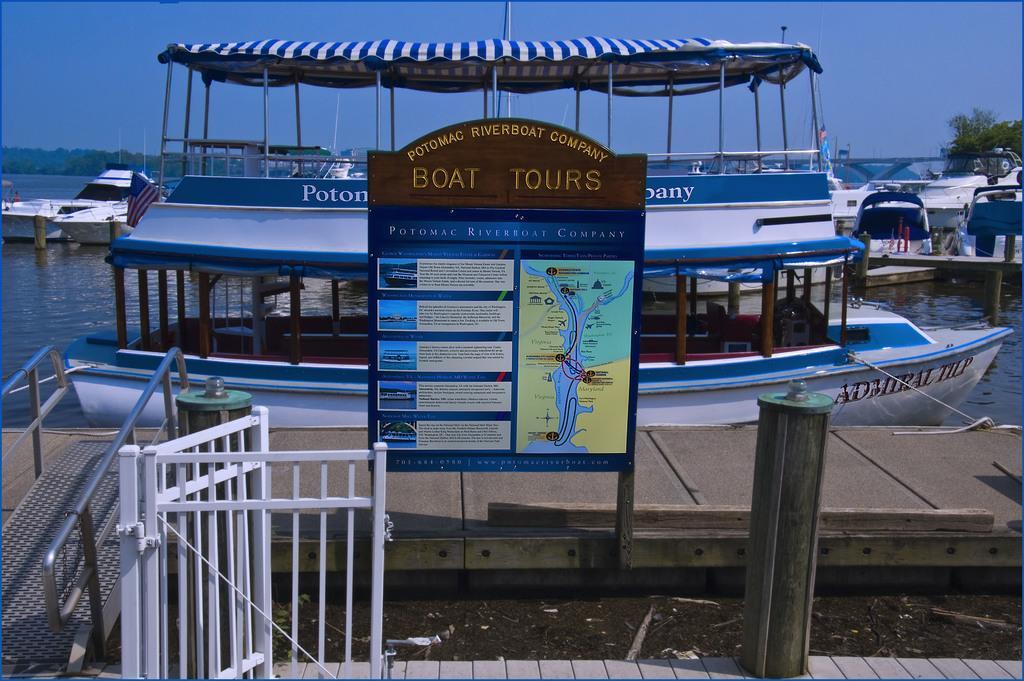Can you describe this image briefly? In the image we can see there are many boats in the water, this is a fence, poster, tree and a sky. This is a pole. 